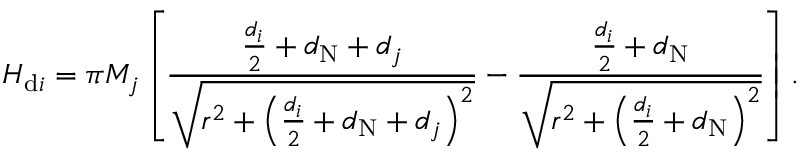Convert formula to latex. <formula><loc_0><loc_0><loc_500><loc_500>H _ { d i } = \pi M _ { j } \left [ \frac { \frac { d _ { i } } { 2 } + d _ { N } + d _ { j } } { \sqrt { r ^ { 2 } + \left ( \frac { d _ { i } } { 2 } + d _ { N } + d _ { j } \right ) ^ { 2 } } } - \frac { \frac { d _ { i } } { 2 } + d _ { N } } { \sqrt { r ^ { 2 } + \left ( \frac { d _ { i } } { 2 } + d _ { N } \right ) ^ { 2 } } } \right ] .</formula> 